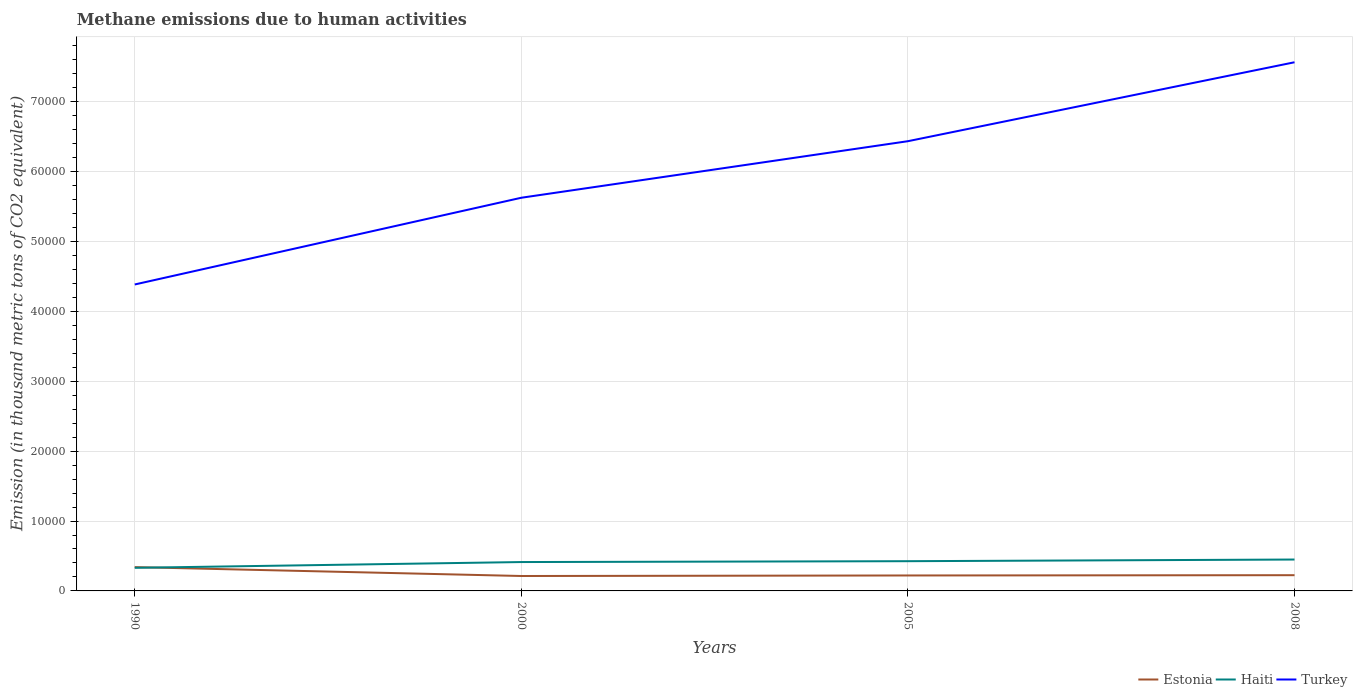How many different coloured lines are there?
Offer a terse response. 3. Is the number of lines equal to the number of legend labels?
Make the answer very short. Yes. Across all years, what is the maximum amount of methane emitted in Haiti?
Offer a very short reply. 3307.8. In which year was the amount of methane emitted in Estonia maximum?
Keep it short and to the point. 2000. What is the total amount of methane emitted in Haiti in the graph?
Provide a succinct answer. -122.8. What is the difference between the highest and the second highest amount of methane emitted in Haiti?
Ensure brevity in your answer.  1184.3. What is the difference between two consecutive major ticks on the Y-axis?
Give a very brief answer. 10000. What is the title of the graph?
Your answer should be compact. Methane emissions due to human activities. Does "Dominica" appear as one of the legend labels in the graph?
Offer a terse response. No. What is the label or title of the Y-axis?
Keep it short and to the point. Emission (in thousand metric tons of CO2 equivalent). What is the Emission (in thousand metric tons of CO2 equivalent) of Estonia in 1990?
Keep it short and to the point. 3408.3. What is the Emission (in thousand metric tons of CO2 equivalent) of Haiti in 1990?
Give a very brief answer. 3307.8. What is the Emission (in thousand metric tons of CO2 equivalent) in Turkey in 1990?
Ensure brevity in your answer.  4.39e+04. What is the Emission (in thousand metric tons of CO2 equivalent) in Estonia in 2000?
Your answer should be very brief. 2136.3. What is the Emission (in thousand metric tons of CO2 equivalent) of Haiti in 2000?
Give a very brief answer. 4132.6. What is the Emission (in thousand metric tons of CO2 equivalent) of Turkey in 2000?
Offer a very short reply. 5.63e+04. What is the Emission (in thousand metric tons of CO2 equivalent) in Estonia in 2005?
Ensure brevity in your answer.  2212.3. What is the Emission (in thousand metric tons of CO2 equivalent) of Haiti in 2005?
Give a very brief answer. 4255.4. What is the Emission (in thousand metric tons of CO2 equivalent) of Turkey in 2005?
Keep it short and to the point. 6.44e+04. What is the Emission (in thousand metric tons of CO2 equivalent) of Estonia in 2008?
Give a very brief answer. 2252. What is the Emission (in thousand metric tons of CO2 equivalent) of Haiti in 2008?
Provide a succinct answer. 4492.1. What is the Emission (in thousand metric tons of CO2 equivalent) in Turkey in 2008?
Offer a very short reply. 7.57e+04. Across all years, what is the maximum Emission (in thousand metric tons of CO2 equivalent) in Estonia?
Keep it short and to the point. 3408.3. Across all years, what is the maximum Emission (in thousand metric tons of CO2 equivalent) in Haiti?
Offer a terse response. 4492.1. Across all years, what is the maximum Emission (in thousand metric tons of CO2 equivalent) in Turkey?
Keep it short and to the point. 7.57e+04. Across all years, what is the minimum Emission (in thousand metric tons of CO2 equivalent) in Estonia?
Your answer should be compact. 2136.3. Across all years, what is the minimum Emission (in thousand metric tons of CO2 equivalent) of Haiti?
Your response must be concise. 3307.8. Across all years, what is the minimum Emission (in thousand metric tons of CO2 equivalent) in Turkey?
Provide a succinct answer. 4.39e+04. What is the total Emission (in thousand metric tons of CO2 equivalent) of Estonia in the graph?
Offer a terse response. 1.00e+04. What is the total Emission (in thousand metric tons of CO2 equivalent) of Haiti in the graph?
Provide a succinct answer. 1.62e+04. What is the total Emission (in thousand metric tons of CO2 equivalent) of Turkey in the graph?
Provide a succinct answer. 2.40e+05. What is the difference between the Emission (in thousand metric tons of CO2 equivalent) of Estonia in 1990 and that in 2000?
Provide a short and direct response. 1272. What is the difference between the Emission (in thousand metric tons of CO2 equivalent) in Haiti in 1990 and that in 2000?
Ensure brevity in your answer.  -824.8. What is the difference between the Emission (in thousand metric tons of CO2 equivalent) of Turkey in 1990 and that in 2000?
Give a very brief answer. -1.24e+04. What is the difference between the Emission (in thousand metric tons of CO2 equivalent) in Estonia in 1990 and that in 2005?
Provide a short and direct response. 1196. What is the difference between the Emission (in thousand metric tons of CO2 equivalent) of Haiti in 1990 and that in 2005?
Make the answer very short. -947.6. What is the difference between the Emission (in thousand metric tons of CO2 equivalent) of Turkey in 1990 and that in 2005?
Your answer should be compact. -2.05e+04. What is the difference between the Emission (in thousand metric tons of CO2 equivalent) of Estonia in 1990 and that in 2008?
Give a very brief answer. 1156.3. What is the difference between the Emission (in thousand metric tons of CO2 equivalent) in Haiti in 1990 and that in 2008?
Provide a succinct answer. -1184.3. What is the difference between the Emission (in thousand metric tons of CO2 equivalent) of Turkey in 1990 and that in 2008?
Provide a succinct answer. -3.18e+04. What is the difference between the Emission (in thousand metric tons of CO2 equivalent) of Estonia in 2000 and that in 2005?
Your answer should be very brief. -76. What is the difference between the Emission (in thousand metric tons of CO2 equivalent) of Haiti in 2000 and that in 2005?
Provide a short and direct response. -122.8. What is the difference between the Emission (in thousand metric tons of CO2 equivalent) of Turkey in 2000 and that in 2005?
Provide a succinct answer. -8092.9. What is the difference between the Emission (in thousand metric tons of CO2 equivalent) in Estonia in 2000 and that in 2008?
Offer a very short reply. -115.7. What is the difference between the Emission (in thousand metric tons of CO2 equivalent) in Haiti in 2000 and that in 2008?
Your answer should be compact. -359.5. What is the difference between the Emission (in thousand metric tons of CO2 equivalent) of Turkey in 2000 and that in 2008?
Ensure brevity in your answer.  -1.94e+04. What is the difference between the Emission (in thousand metric tons of CO2 equivalent) in Estonia in 2005 and that in 2008?
Provide a succinct answer. -39.7. What is the difference between the Emission (in thousand metric tons of CO2 equivalent) of Haiti in 2005 and that in 2008?
Provide a short and direct response. -236.7. What is the difference between the Emission (in thousand metric tons of CO2 equivalent) in Turkey in 2005 and that in 2008?
Your response must be concise. -1.13e+04. What is the difference between the Emission (in thousand metric tons of CO2 equivalent) of Estonia in 1990 and the Emission (in thousand metric tons of CO2 equivalent) of Haiti in 2000?
Provide a succinct answer. -724.3. What is the difference between the Emission (in thousand metric tons of CO2 equivalent) of Estonia in 1990 and the Emission (in thousand metric tons of CO2 equivalent) of Turkey in 2000?
Offer a very short reply. -5.29e+04. What is the difference between the Emission (in thousand metric tons of CO2 equivalent) in Haiti in 1990 and the Emission (in thousand metric tons of CO2 equivalent) in Turkey in 2000?
Offer a terse response. -5.30e+04. What is the difference between the Emission (in thousand metric tons of CO2 equivalent) of Estonia in 1990 and the Emission (in thousand metric tons of CO2 equivalent) of Haiti in 2005?
Give a very brief answer. -847.1. What is the difference between the Emission (in thousand metric tons of CO2 equivalent) of Estonia in 1990 and the Emission (in thousand metric tons of CO2 equivalent) of Turkey in 2005?
Keep it short and to the point. -6.09e+04. What is the difference between the Emission (in thousand metric tons of CO2 equivalent) of Haiti in 1990 and the Emission (in thousand metric tons of CO2 equivalent) of Turkey in 2005?
Ensure brevity in your answer.  -6.10e+04. What is the difference between the Emission (in thousand metric tons of CO2 equivalent) in Estonia in 1990 and the Emission (in thousand metric tons of CO2 equivalent) in Haiti in 2008?
Your answer should be compact. -1083.8. What is the difference between the Emission (in thousand metric tons of CO2 equivalent) in Estonia in 1990 and the Emission (in thousand metric tons of CO2 equivalent) in Turkey in 2008?
Offer a terse response. -7.22e+04. What is the difference between the Emission (in thousand metric tons of CO2 equivalent) in Haiti in 1990 and the Emission (in thousand metric tons of CO2 equivalent) in Turkey in 2008?
Your response must be concise. -7.23e+04. What is the difference between the Emission (in thousand metric tons of CO2 equivalent) of Estonia in 2000 and the Emission (in thousand metric tons of CO2 equivalent) of Haiti in 2005?
Make the answer very short. -2119.1. What is the difference between the Emission (in thousand metric tons of CO2 equivalent) in Estonia in 2000 and the Emission (in thousand metric tons of CO2 equivalent) in Turkey in 2005?
Offer a terse response. -6.22e+04. What is the difference between the Emission (in thousand metric tons of CO2 equivalent) in Haiti in 2000 and the Emission (in thousand metric tons of CO2 equivalent) in Turkey in 2005?
Your answer should be compact. -6.02e+04. What is the difference between the Emission (in thousand metric tons of CO2 equivalent) in Estonia in 2000 and the Emission (in thousand metric tons of CO2 equivalent) in Haiti in 2008?
Your answer should be compact. -2355.8. What is the difference between the Emission (in thousand metric tons of CO2 equivalent) of Estonia in 2000 and the Emission (in thousand metric tons of CO2 equivalent) of Turkey in 2008?
Provide a short and direct response. -7.35e+04. What is the difference between the Emission (in thousand metric tons of CO2 equivalent) of Haiti in 2000 and the Emission (in thousand metric tons of CO2 equivalent) of Turkey in 2008?
Your response must be concise. -7.15e+04. What is the difference between the Emission (in thousand metric tons of CO2 equivalent) of Estonia in 2005 and the Emission (in thousand metric tons of CO2 equivalent) of Haiti in 2008?
Provide a succinct answer. -2279.8. What is the difference between the Emission (in thousand metric tons of CO2 equivalent) in Estonia in 2005 and the Emission (in thousand metric tons of CO2 equivalent) in Turkey in 2008?
Your answer should be very brief. -7.34e+04. What is the difference between the Emission (in thousand metric tons of CO2 equivalent) of Haiti in 2005 and the Emission (in thousand metric tons of CO2 equivalent) of Turkey in 2008?
Provide a succinct answer. -7.14e+04. What is the average Emission (in thousand metric tons of CO2 equivalent) in Estonia per year?
Ensure brevity in your answer.  2502.22. What is the average Emission (in thousand metric tons of CO2 equivalent) in Haiti per year?
Ensure brevity in your answer.  4046.97. What is the average Emission (in thousand metric tons of CO2 equivalent) in Turkey per year?
Your response must be concise. 6.00e+04. In the year 1990, what is the difference between the Emission (in thousand metric tons of CO2 equivalent) of Estonia and Emission (in thousand metric tons of CO2 equivalent) of Haiti?
Your response must be concise. 100.5. In the year 1990, what is the difference between the Emission (in thousand metric tons of CO2 equivalent) in Estonia and Emission (in thousand metric tons of CO2 equivalent) in Turkey?
Provide a short and direct response. -4.04e+04. In the year 1990, what is the difference between the Emission (in thousand metric tons of CO2 equivalent) of Haiti and Emission (in thousand metric tons of CO2 equivalent) of Turkey?
Your response must be concise. -4.05e+04. In the year 2000, what is the difference between the Emission (in thousand metric tons of CO2 equivalent) in Estonia and Emission (in thousand metric tons of CO2 equivalent) in Haiti?
Give a very brief answer. -1996.3. In the year 2000, what is the difference between the Emission (in thousand metric tons of CO2 equivalent) in Estonia and Emission (in thousand metric tons of CO2 equivalent) in Turkey?
Ensure brevity in your answer.  -5.41e+04. In the year 2000, what is the difference between the Emission (in thousand metric tons of CO2 equivalent) in Haiti and Emission (in thousand metric tons of CO2 equivalent) in Turkey?
Offer a terse response. -5.21e+04. In the year 2005, what is the difference between the Emission (in thousand metric tons of CO2 equivalent) of Estonia and Emission (in thousand metric tons of CO2 equivalent) of Haiti?
Your answer should be compact. -2043.1. In the year 2005, what is the difference between the Emission (in thousand metric tons of CO2 equivalent) in Estonia and Emission (in thousand metric tons of CO2 equivalent) in Turkey?
Make the answer very short. -6.21e+04. In the year 2005, what is the difference between the Emission (in thousand metric tons of CO2 equivalent) in Haiti and Emission (in thousand metric tons of CO2 equivalent) in Turkey?
Make the answer very short. -6.01e+04. In the year 2008, what is the difference between the Emission (in thousand metric tons of CO2 equivalent) in Estonia and Emission (in thousand metric tons of CO2 equivalent) in Haiti?
Your response must be concise. -2240.1. In the year 2008, what is the difference between the Emission (in thousand metric tons of CO2 equivalent) of Estonia and Emission (in thousand metric tons of CO2 equivalent) of Turkey?
Provide a short and direct response. -7.34e+04. In the year 2008, what is the difference between the Emission (in thousand metric tons of CO2 equivalent) of Haiti and Emission (in thousand metric tons of CO2 equivalent) of Turkey?
Offer a terse response. -7.12e+04. What is the ratio of the Emission (in thousand metric tons of CO2 equivalent) in Estonia in 1990 to that in 2000?
Provide a succinct answer. 1.6. What is the ratio of the Emission (in thousand metric tons of CO2 equivalent) in Haiti in 1990 to that in 2000?
Keep it short and to the point. 0.8. What is the ratio of the Emission (in thousand metric tons of CO2 equivalent) in Turkey in 1990 to that in 2000?
Your answer should be compact. 0.78. What is the ratio of the Emission (in thousand metric tons of CO2 equivalent) in Estonia in 1990 to that in 2005?
Make the answer very short. 1.54. What is the ratio of the Emission (in thousand metric tons of CO2 equivalent) of Haiti in 1990 to that in 2005?
Keep it short and to the point. 0.78. What is the ratio of the Emission (in thousand metric tons of CO2 equivalent) in Turkey in 1990 to that in 2005?
Your response must be concise. 0.68. What is the ratio of the Emission (in thousand metric tons of CO2 equivalent) in Estonia in 1990 to that in 2008?
Ensure brevity in your answer.  1.51. What is the ratio of the Emission (in thousand metric tons of CO2 equivalent) of Haiti in 1990 to that in 2008?
Your response must be concise. 0.74. What is the ratio of the Emission (in thousand metric tons of CO2 equivalent) in Turkey in 1990 to that in 2008?
Provide a short and direct response. 0.58. What is the ratio of the Emission (in thousand metric tons of CO2 equivalent) of Estonia in 2000 to that in 2005?
Ensure brevity in your answer.  0.97. What is the ratio of the Emission (in thousand metric tons of CO2 equivalent) in Haiti in 2000 to that in 2005?
Offer a terse response. 0.97. What is the ratio of the Emission (in thousand metric tons of CO2 equivalent) of Turkey in 2000 to that in 2005?
Offer a very short reply. 0.87. What is the ratio of the Emission (in thousand metric tons of CO2 equivalent) in Estonia in 2000 to that in 2008?
Provide a succinct answer. 0.95. What is the ratio of the Emission (in thousand metric tons of CO2 equivalent) in Haiti in 2000 to that in 2008?
Provide a short and direct response. 0.92. What is the ratio of the Emission (in thousand metric tons of CO2 equivalent) of Turkey in 2000 to that in 2008?
Offer a very short reply. 0.74. What is the ratio of the Emission (in thousand metric tons of CO2 equivalent) of Estonia in 2005 to that in 2008?
Offer a very short reply. 0.98. What is the ratio of the Emission (in thousand metric tons of CO2 equivalent) of Haiti in 2005 to that in 2008?
Your answer should be very brief. 0.95. What is the ratio of the Emission (in thousand metric tons of CO2 equivalent) of Turkey in 2005 to that in 2008?
Keep it short and to the point. 0.85. What is the difference between the highest and the second highest Emission (in thousand metric tons of CO2 equivalent) in Estonia?
Give a very brief answer. 1156.3. What is the difference between the highest and the second highest Emission (in thousand metric tons of CO2 equivalent) of Haiti?
Make the answer very short. 236.7. What is the difference between the highest and the second highest Emission (in thousand metric tons of CO2 equivalent) of Turkey?
Keep it short and to the point. 1.13e+04. What is the difference between the highest and the lowest Emission (in thousand metric tons of CO2 equivalent) of Estonia?
Your answer should be very brief. 1272. What is the difference between the highest and the lowest Emission (in thousand metric tons of CO2 equivalent) in Haiti?
Your answer should be very brief. 1184.3. What is the difference between the highest and the lowest Emission (in thousand metric tons of CO2 equivalent) in Turkey?
Your answer should be very brief. 3.18e+04. 